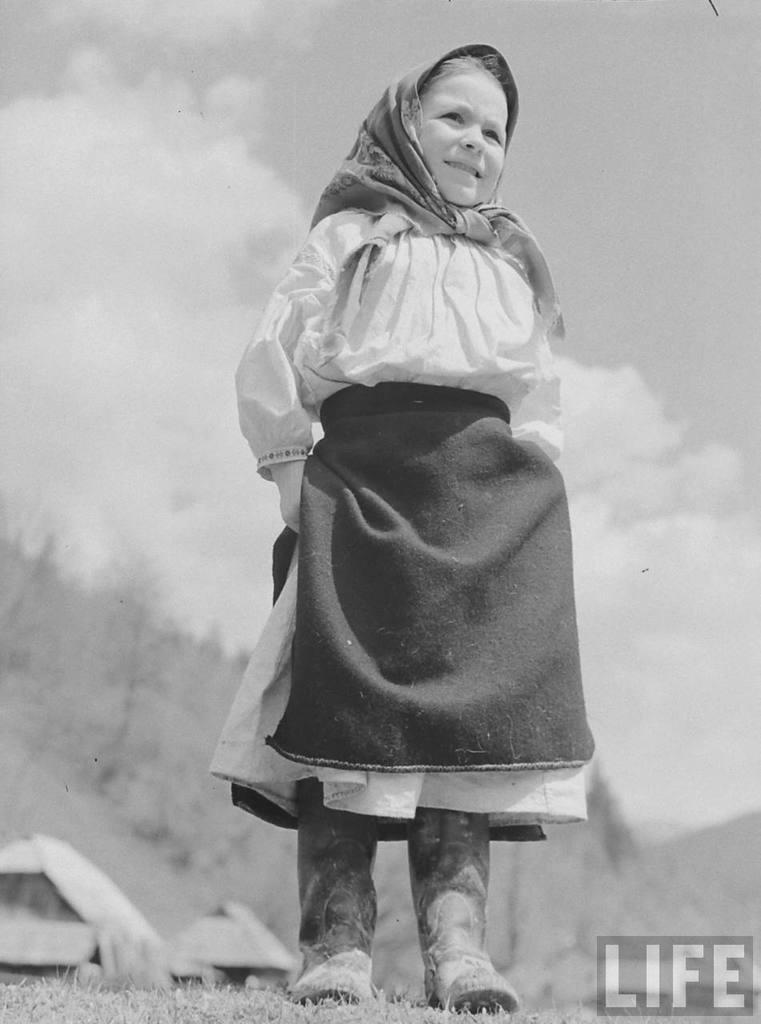Who is the main subject in the image? There is a girl in the image. What is the girl wearing in the image? The girl is wearing a scarf in the image. What type of terrain is visible at the bottom of the image? There is grass at the bottom of the image. What can be seen in the distance in the image? There are mountains in the background of the image. What type of vegetation is present in the background of the image? There are plants in the background of the image. What type of sugar is being used to create the paste on the rat in the image? There is no sugar, paste, or rat present in the image. 